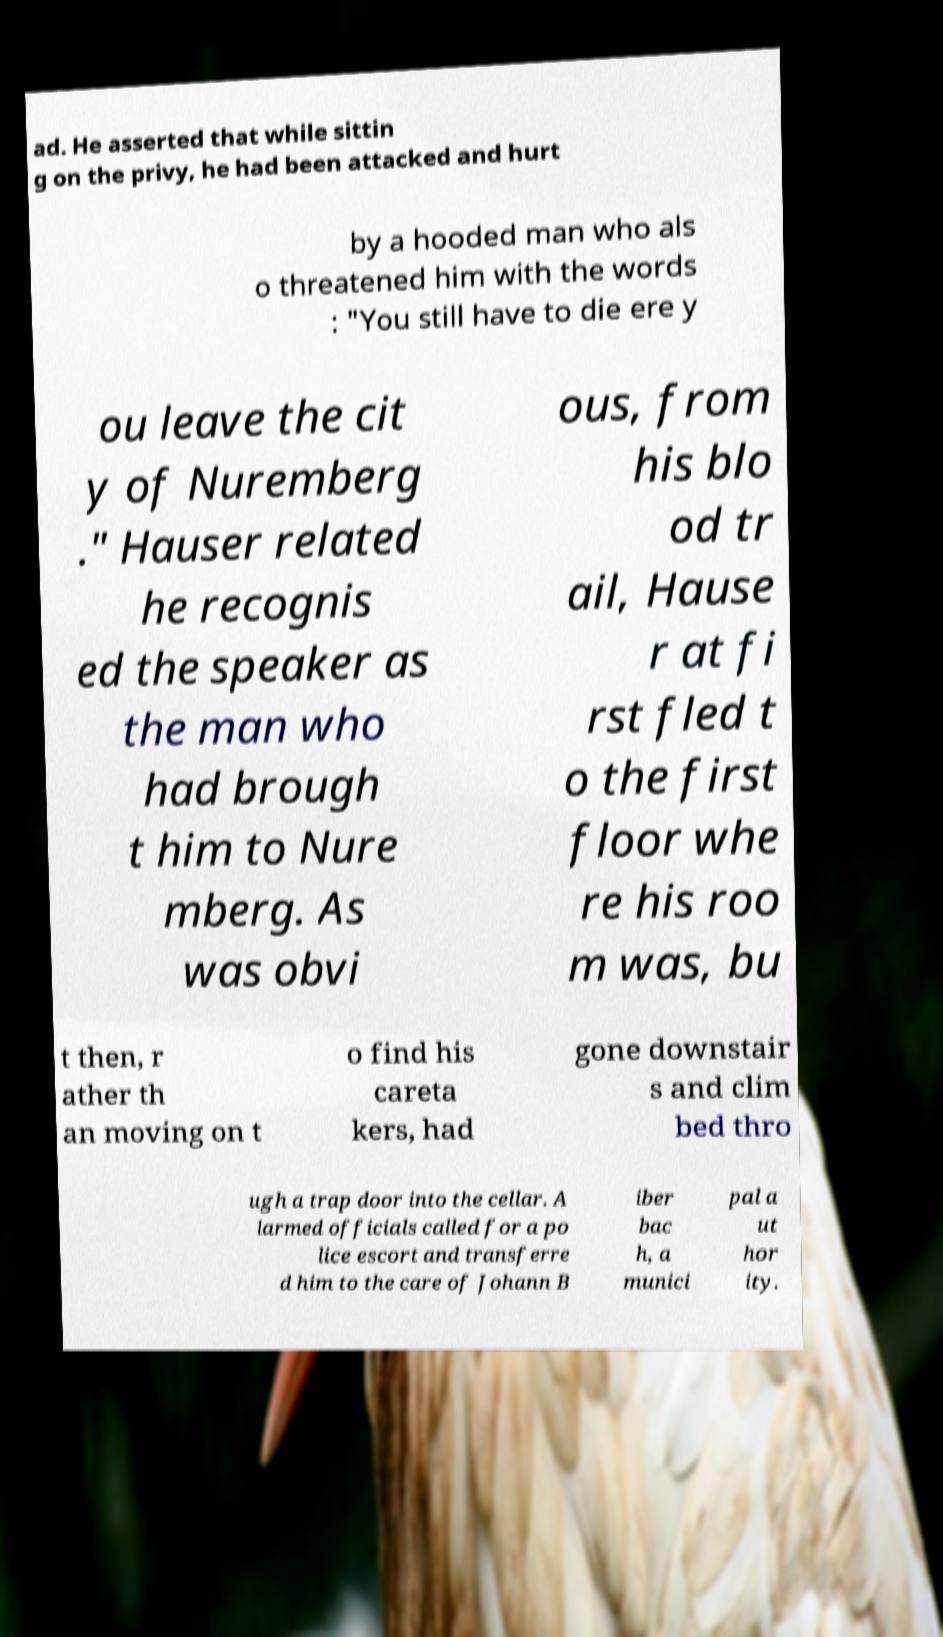Could you assist in decoding the text presented in this image and type it out clearly? ad. He asserted that while sittin g on the privy, he had been attacked and hurt by a hooded man who als o threatened him with the words : "You still have to die ere y ou leave the cit y of Nuremberg ." Hauser related he recognis ed the speaker as the man who had brough t him to Nure mberg. As was obvi ous, from his blo od tr ail, Hause r at fi rst fled t o the first floor whe re his roo m was, bu t then, r ather th an moving on t o find his careta kers, had gone downstair s and clim bed thro ugh a trap door into the cellar. A larmed officials called for a po lice escort and transferre d him to the care of Johann B iber bac h, a munici pal a ut hor ity. 